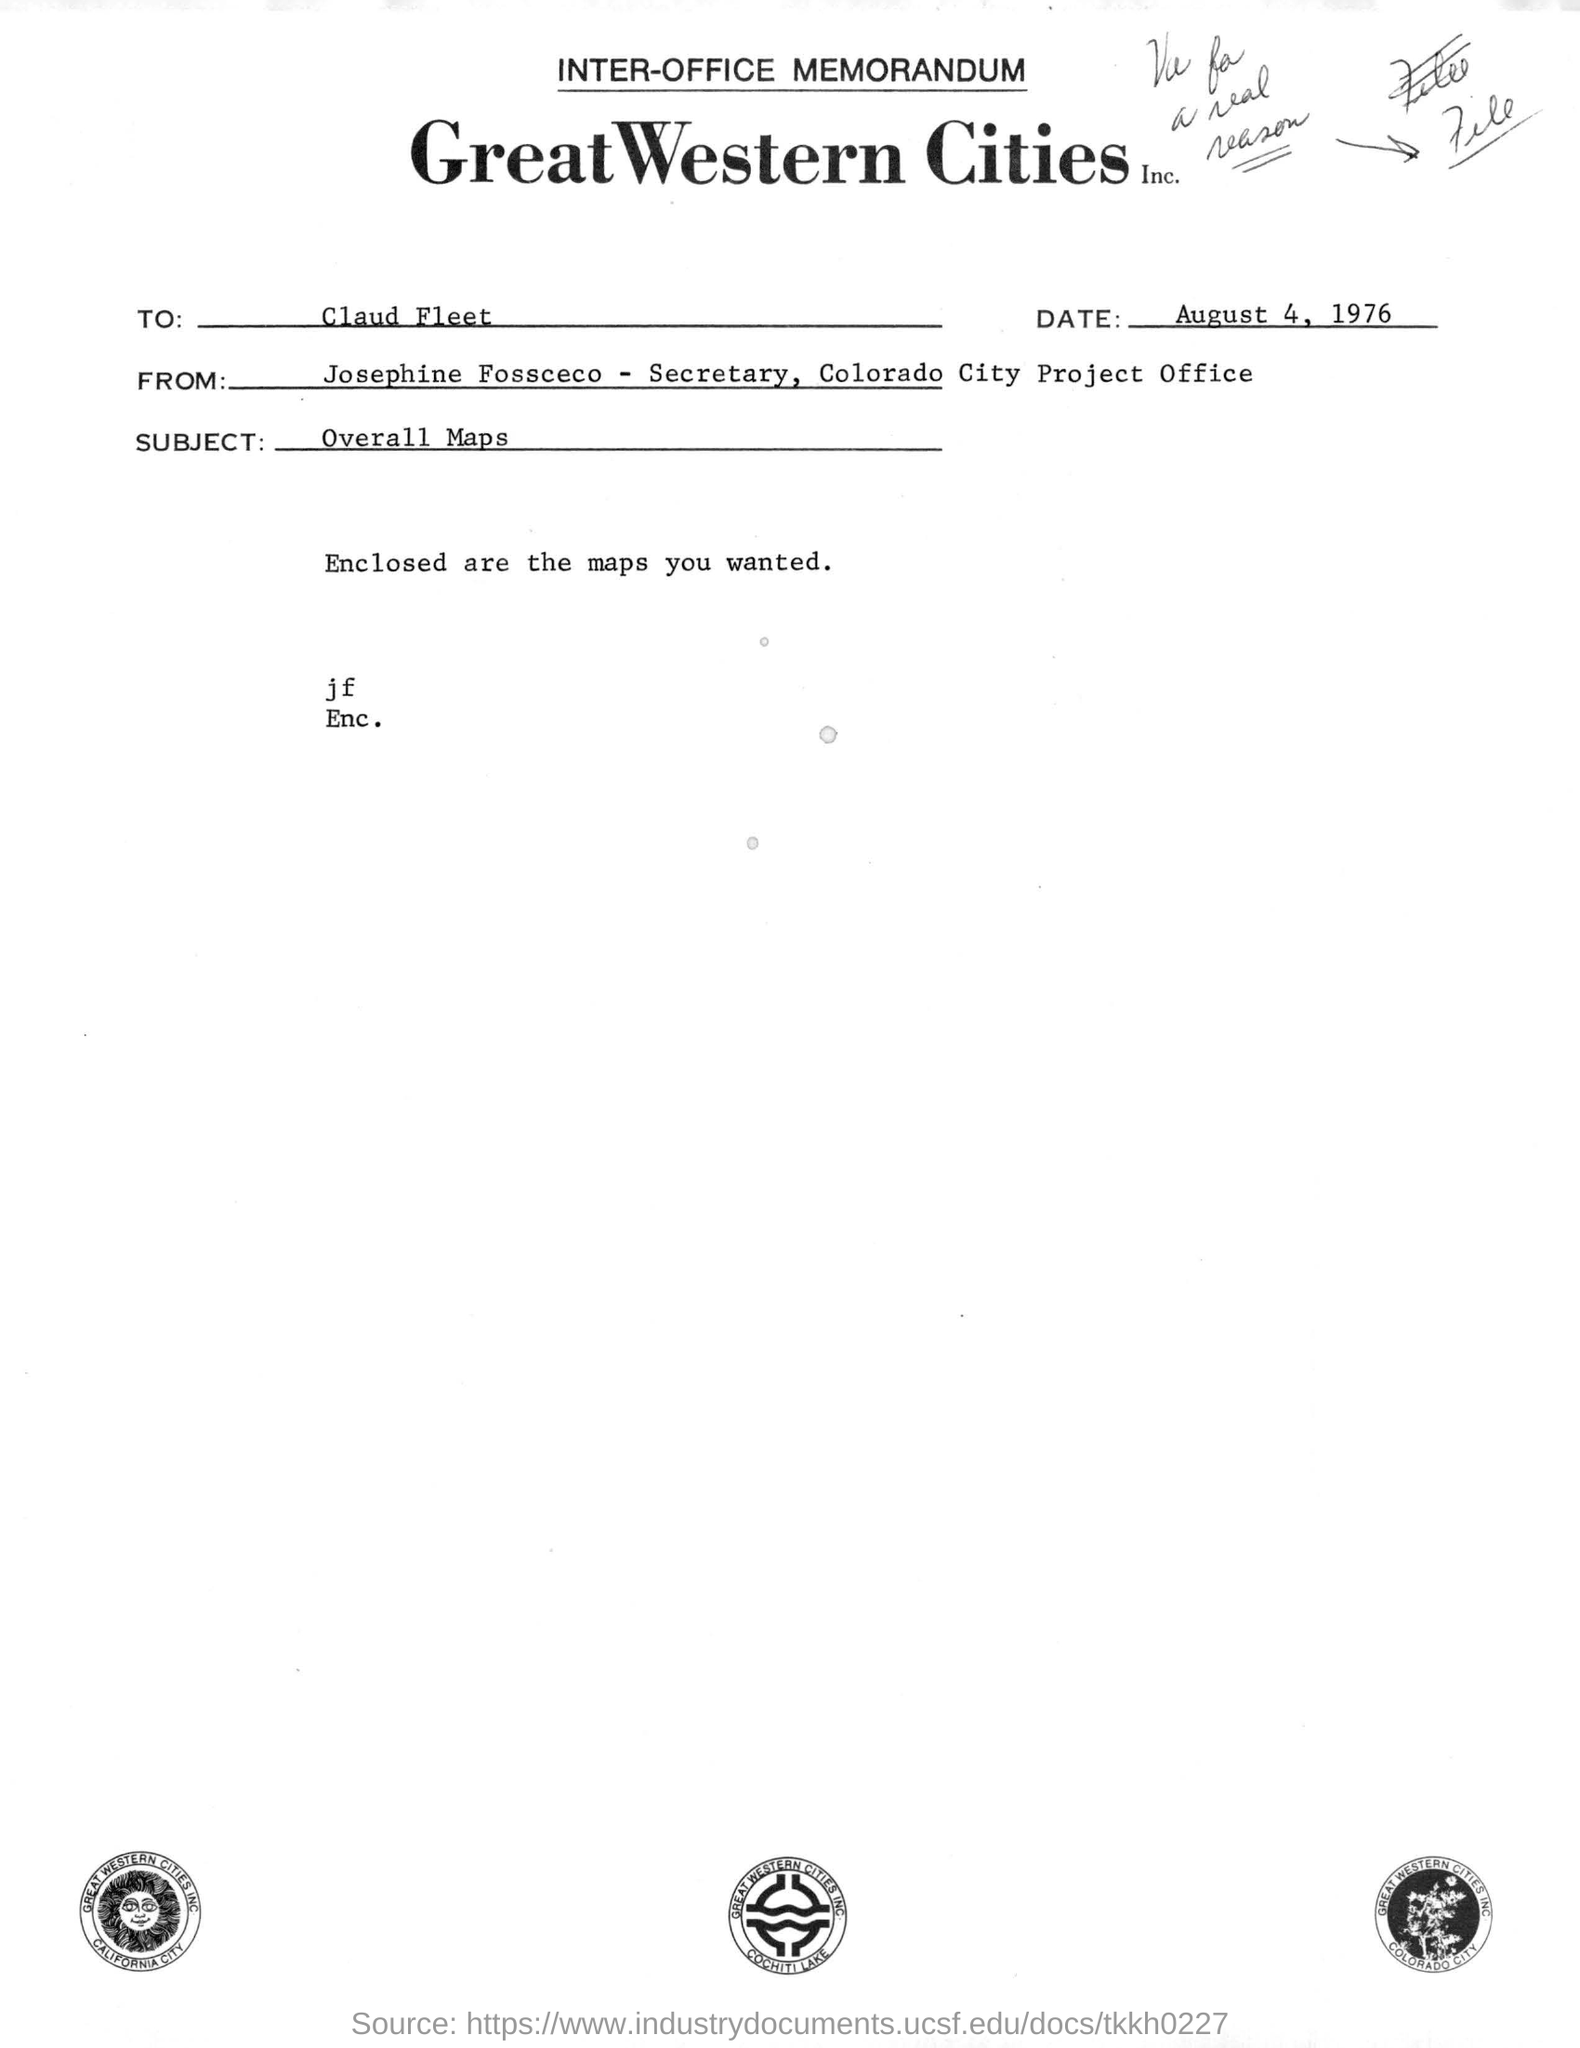Mention a couple of crucial points in this snapshot. The date of the document is August 4, 1976. The memorandum in question states that the date mentioned is August 4, 1976. This letter includes maps as enclosed. The subject of this letter is "overall maps. To whom this letter is addressed: Claud Fleet. 